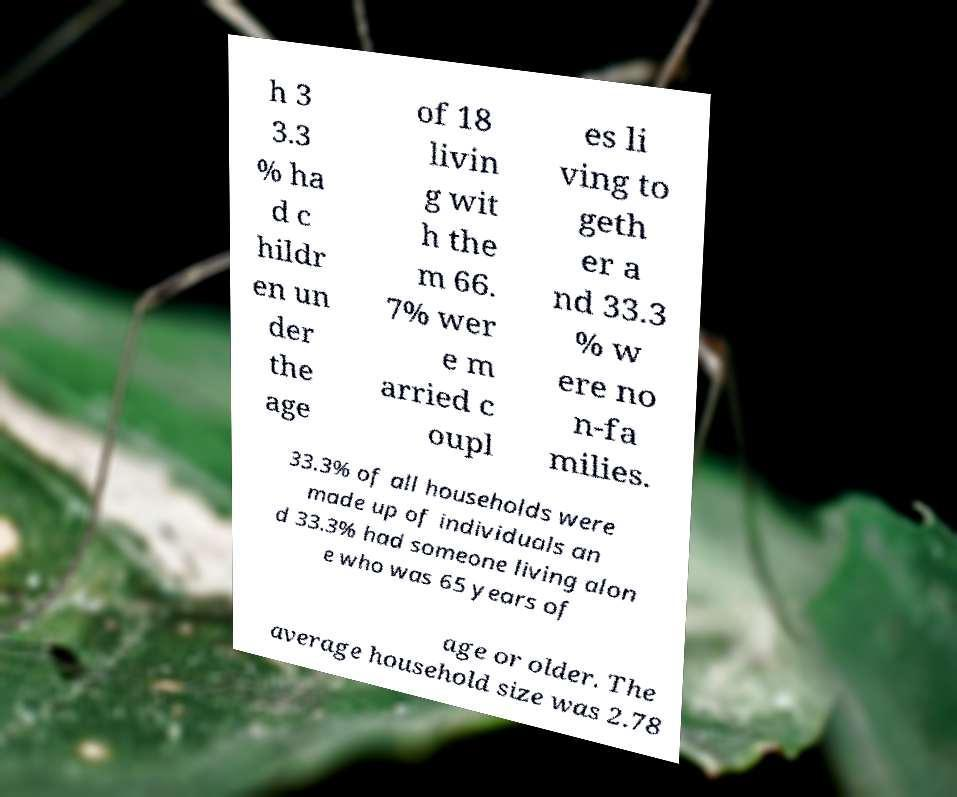Could you assist in decoding the text presented in this image and type it out clearly? h 3 3.3 % ha d c hildr en un der the age of 18 livin g wit h the m 66. 7% wer e m arried c oupl es li ving to geth er a nd 33.3 % w ere no n-fa milies. 33.3% of all households were made up of individuals an d 33.3% had someone living alon e who was 65 years of age or older. The average household size was 2.78 